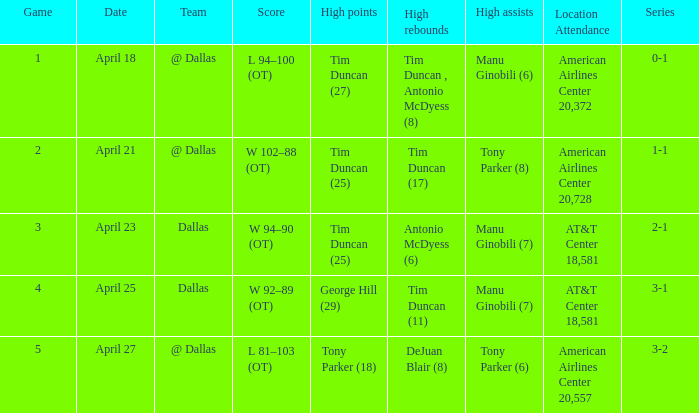When 5 is the game who has the highest amount of points? Tony Parker (18). 